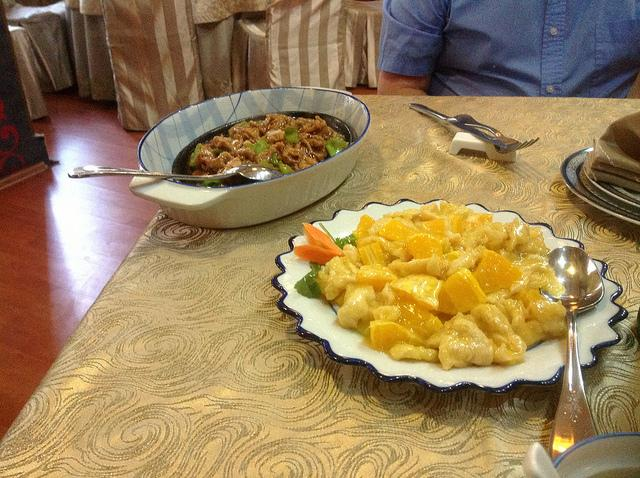What utensil is missing from this table? knife 